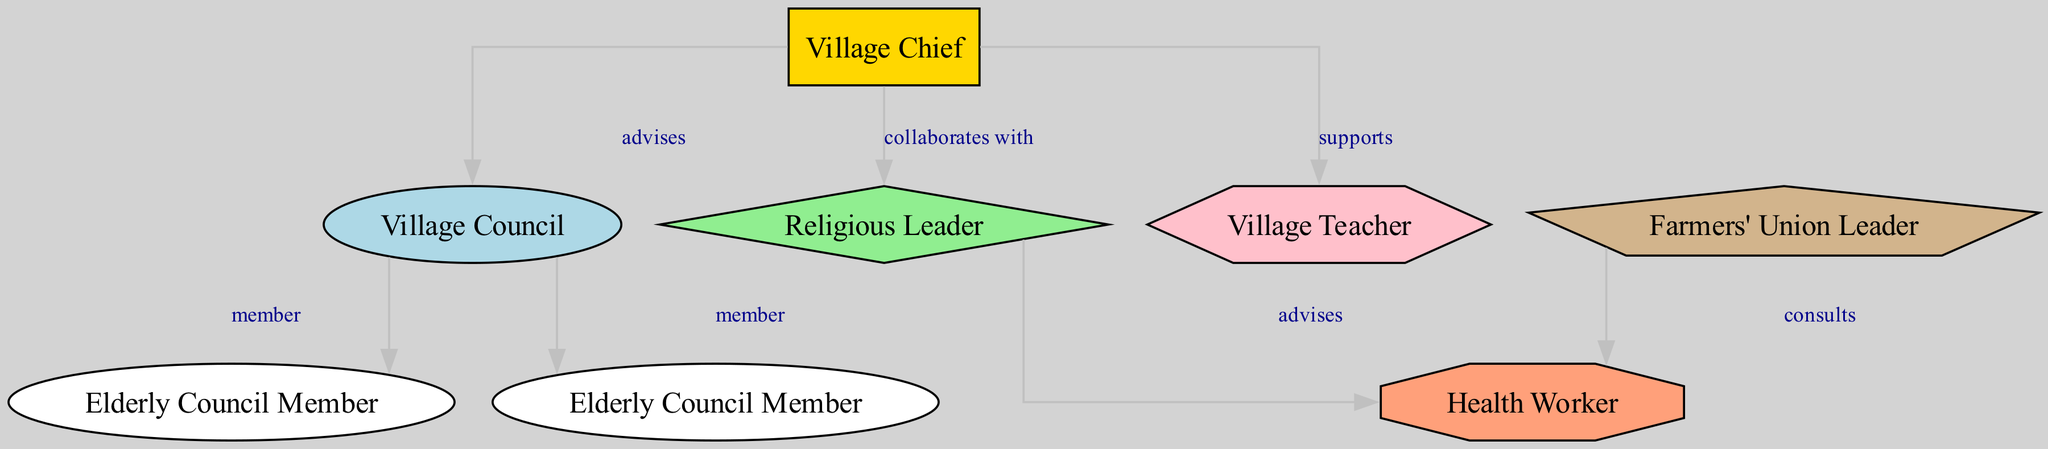What is the top node in the hierarchy? The top node in the hierarchy is the Village Chief, as it has no incoming edges and connects to other nodes, indicating leadership.
Answer: Village Chief How many edges are in the diagram? Counting the connections (edges) drawn between the nodes, there are 7 distinct relationships represented.
Answer: 7 Which two nodes does the Village Chief collaborate with? The Village Chief has collaboration edges with the Religious Leader and the Village Teacher, indicating joint efforts or mutual support.
Answer: Religious Leader, Village Teacher How many members are in the Village Council? The Village Council has two members, Elderly Council Member 1 and Elderly Council Member 2, as indicated by the direct connections to the council node.
Answer: 2 Which node advises the Health Worker? The Health Worker is advised by both the Religious Leader and the Farmers' Union Leader, showing that multiple figures influence health-related matters in the village.
Answer: Religious Leader, Farmers' Union Leader What shape represents the Village Chief in the diagram? In the diagram, the Village Chief is represented by a rectangle, which is one of the defined shapes for the nodes indicating its primary role in village leadership.
Answer: Rectangle Who is supported by the Village Chief? The Village Teacher is supported by the Village Chief, showing the Chief's involvement in educational aspects of the village.
Answer: Village Teacher What role does the Farmers' Union Leader play in relation to the Health Worker? The Farmers' Union Leader consults the Health Worker, indicating a relationship where agricultural interests may intersect with health-related decisions.
Answer: Consults Which node is directly connected to the council but not to the chief? The two Elderly Council Members are directly connected to the Village Council but do not have a direct connection to the Village Chief in the diagram.
Answer: Elderly Council Member 1, Elderly Council Member 2 